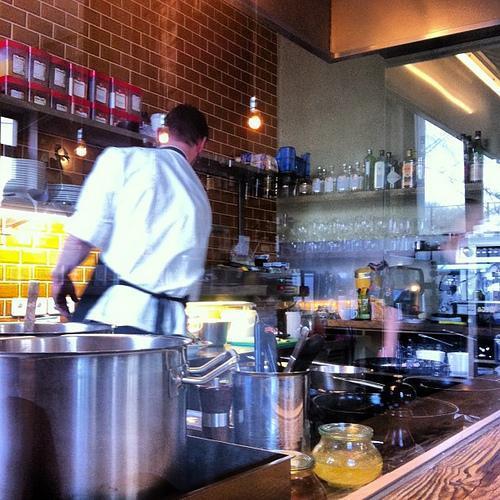How many people are there?
Give a very brief answer. 1. 